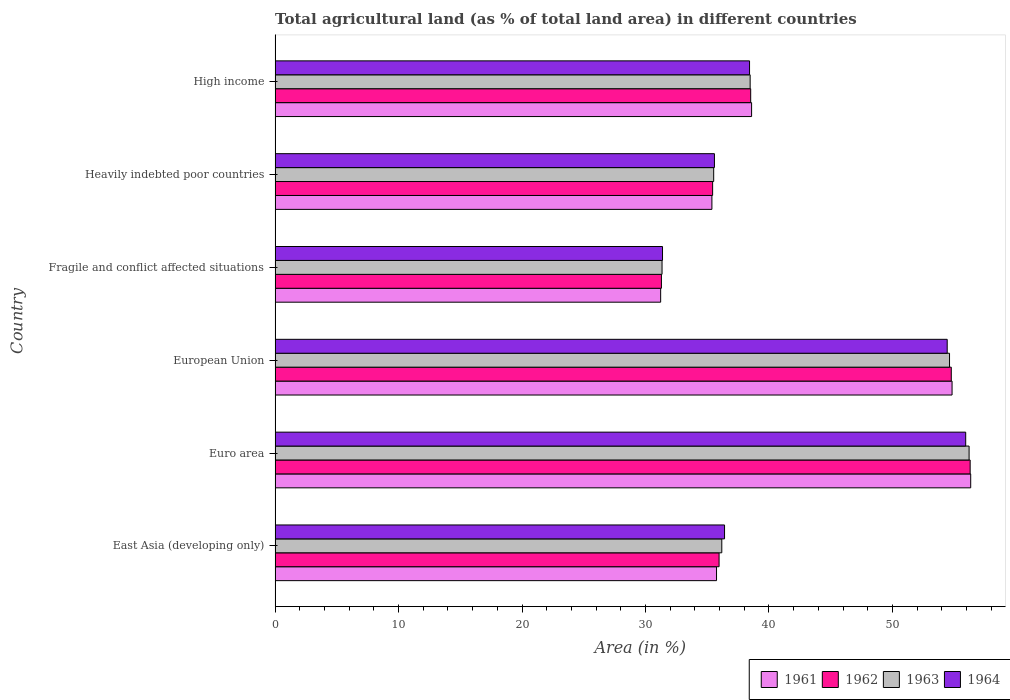Are the number of bars on each tick of the Y-axis equal?
Your answer should be very brief. Yes. How many bars are there on the 1st tick from the top?
Make the answer very short. 4. What is the label of the 5th group of bars from the top?
Your response must be concise. Euro area. In how many cases, is the number of bars for a given country not equal to the number of legend labels?
Provide a short and direct response. 0. What is the percentage of agricultural land in 1964 in Euro area?
Offer a terse response. 55.94. Across all countries, what is the maximum percentage of agricultural land in 1962?
Ensure brevity in your answer.  56.3. Across all countries, what is the minimum percentage of agricultural land in 1962?
Make the answer very short. 31.29. In which country was the percentage of agricultural land in 1963 maximum?
Provide a succinct answer. Euro area. In which country was the percentage of agricultural land in 1962 minimum?
Your answer should be compact. Fragile and conflict affected situations. What is the total percentage of agricultural land in 1961 in the graph?
Keep it short and to the point. 252.13. What is the difference between the percentage of agricultural land in 1961 in Euro area and that in High income?
Your response must be concise. 17.75. What is the difference between the percentage of agricultural land in 1961 in East Asia (developing only) and the percentage of agricultural land in 1964 in European Union?
Your answer should be very brief. -18.68. What is the average percentage of agricultural land in 1964 per country?
Keep it short and to the point. 42.03. What is the difference between the percentage of agricultural land in 1964 and percentage of agricultural land in 1961 in Euro area?
Your response must be concise. -0.4. In how many countries, is the percentage of agricultural land in 1963 greater than 46 %?
Keep it short and to the point. 2. What is the ratio of the percentage of agricultural land in 1963 in East Asia (developing only) to that in Fragile and conflict affected situations?
Give a very brief answer. 1.15. What is the difference between the highest and the second highest percentage of agricultural land in 1962?
Give a very brief answer. 1.53. What is the difference between the highest and the lowest percentage of agricultural land in 1964?
Offer a terse response. 24.56. Is the sum of the percentage of agricultural land in 1961 in Euro area and High income greater than the maximum percentage of agricultural land in 1964 across all countries?
Offer a terse response. Yes. Is it the case that in every country, the sum of the percentage of agricultural land in 1963 and percentage of agricultural land in 1964 is greater than the sum of percentage of agricultural land in 1961 and percentage of agricultural land in 1962?
Your answer should be very brief. No. What does the 1st bar from the top in Euro area represents?
Offer a very short reply. 1964. What does the 1st bar from the bottom in High income represents?
Offer a very short reply. 1961. Are all the bars in the graph horizontal?
Give a very brief answer. Yes. How many countries are there in the graph?
Make the answer very short. 6. Are the values on the major ticks of X-axis written in scientific E-notation?
Offer a terse response. No. Does the graph contain any zero values?
Keep it short and to the point. No. Does the graph contain grids?
Your answer should be very brief. No. How many legend labels are there?
Your answer should be compact. 4. How are the legend labels stacked?
Offer a very short reply. Horizontal. What is the title of the graph?
Your response must be concise. Total agricultural land (as % of total land area) in different countries. Does "1965" appear as one of the legend labels in the graph?
Keep it short and to the point. No. What is the label or title of the X-axis?
Keep it short and to the point. Area (in %). What is the label or title of the Y-axis?
Your answer should be compact. Country. What is the Area (in %) of 1961 in East Asia (developing only)?
Ensure brevity in your answer.  35.75. What is the Area (in %) of 1962 in East Asia (developing only)?
Make the answer very short. 35.96. What is the Area (in %) of 1963 in East Asia (developing only)?
Provide a short and direct response. 36.18. What is the Area (in %) of 1964 in East Asia (developing only)?
Your answer should be compact. 36.4. What is the Area (in %) in 1961 in Euro area?
Offer a terse response. 56.34. What is the Area (in %) of 1962 in Euro area?
Offer a terse response. 56.3. What is the Area (in %) of 1963 in Euro area?
Make the answer very short. 56.21. What is the Area (in %) of 1964 in Euro area?
Provide a short and direct response. 55.94. What is the Area (in %) of 1961 in European Union?
Keep it short and to the point. 54.83. What is the Area (in %) of 1962 in European Union?
Make the answer very short. 54.77. What is the Area (in %) of 1963 in European Union?
Your answer should be compact. 54.63. What is the Area (in %) in 1964 in European Union?
Ensure brevity in your answer.  54.44. What is the Area (in %) of 1961 in Fragile and conflict affected situations?
Ensure brevity in your answer.  31.23. What is the Area (in %) of 1962 in Fragile and conflict affected situations?
Provide a short and direct response. 31.29. What is the Area (in %) in 1963 in Fragile and conflict affected situations?
Your answer should be compact. 31.34. What is the Area (in %) of 1964 in Fragile and conflict affected situations?
Offer a terse response. 31.38. What is the Area (in %) of 1961 in Heavily indebted poor countries?
Provide a short and direct response. 35.38. What is the Area (in %) in 1962 in Heavily indebted poor countries?
Your response must be concise. 35.44. What is the Area (in %) in 1963 in Heavily indebted poor countries?
Offer a terse response. 35.52. What is the Area (in %) in 1964 in Heavily indebted poor countries?
Your response must be concise. 35.59. What is the Area (in %) in 1961 in High income?
Provide a succinct answer. 38.59. What is the Area (in %) of 1962 in High income?
Your answer should be compact. 38.52. What is the Area (in %) of 1963 in High income?
Keep it short and to the point. 38.48. What is the Area (in %) in 1964 in High income?
Your answer should be compact. 38.43. Across all countries, what is the maximum Area (in %) in 1961?
Keep it short and to the point. 56.34. Across all countries, what is the maximum Area (in %) in 1962?
Give a very brief answer. 56.3. Across all countries, what is the maximum Area (in %) in 1963?
Provide a succinct answer. 56.21. Across all countries, what is the maximum Area (in %) in 1964?
Keep it short and to the point. 55.94. Across all countries, what is the minimum Area (in %) in 1961?
Your answer should be compact. 31.23. Across all countries, what is the minimum Area (in %) of 1962?
Give a very brief answer. 31.29. Across all countries, what is the minimum Area (in %) in 1963?
Keep it short and to the point. 31.34. Across all countries, what is the minimum Area (in %) in 1964?
Keep it short and to the point. 31.38. What is the total Area (in %) in 1961 in the graph?
Give a very brief answer. 252.13. What is the total Area (in %) of 1962 in the graph?
Your response must be concise. 252.28. What is the total Area (in %) of 1963 in the graph?
Your response must be concise. 252.36. What is the total Area (in %) of 1964 in the graph?
Provide a short and direct response. 252.17. What is the difference between the Area (in %) in 1961 in East Asia (developing only) and that in Euro area?
Make the answer very short. -20.59. What is the difference between the Area (in %) in 1962 in East Asia (developing only) and that in Euro area?
Give a very brief answer. -20.34. What is the difference between the Area (in %) in 1963 in East Asia (developing only) and that in Euro area?
Provide a succinct answer. -20.03. What is the difference between the Area (in %) of 1964 in East Asia (developing only) and that in Euro area?
Keep it short and to the point. -19.53. What is the difference between the Area (in %) of 1961 in East Asia (developing only) and that in European Union?
Your answer should be compact. -19.08. What is the difference between the Area (in %) in 1962 in East Asia (developing only) and that in European Union?
Keep it short and to the point. -18.81. What is the difference between the Area (in %) in 1963 in East Asia (developing only) and that in European Union?
Ensure brevity in your answer.  -18.45. What is the difference between the Area (in %) in 1964 in East Asia (developing only) and that in European Union?
Ensure brevity in your answer.  -18.03. What is the difference between the Area (in %) in 1961 in East Asia (developing only) and that in Fragile and conflict affected situations?
Your answer should be very brief. 4.53. What is the difference between the Area (in %) of 1962 in East Asia (developing only) and that in Fragile and conflict affected situations?
Keep it short and to the point. 4.67. What is the difference between the Area (in %) of 1963 in East Asia (developing only) and that in Fragile and conflict affected situations?
Your response must be concise. 4.84. What is the difference between the Area (in %) of 1964 in East Asia (developing only) and that in Fragile and conflict affected situations?
Provide a short and direct response. 5.02. What is the difference between the Area (in %) of 1961 in East Asia (developing only) and that in Heavily indebted poor countries?
Your response must be concise. 0.37. What is the difference between the Area (in %) of 1962 in East Asia (developing only) and that in Heavily indebted poor countries?
Your response must be concise. 0.52. What is the difference between the Area (in %) of 1963 in East Asia (developing only) and that in Heavily indebted poor countries?
Ensure brevity in your answer.  0.66. What is the difference between the Area (in %) of 1964 in East Asia (developing only) and that in Heavily indebted poor countries?
Provide a succinct answer. 0.82. What is the difference between the Area (in %) of 1961 in East Asia (developing only) and that in High income?
Make the answer very short. -2.84. What is the difference between the Area (in %) of 1962 in East Asia (developing only) and that in High income?
Your answer should be compact. -2.56. What is the difference between the Area (in %) of 1963 in East Asia (developing only) and that in High income?
Provide a short and direct response. -2.3. What is the difference between the Area (in %) of 1964 in East Asia (developing only) and that in High income?
Ensure brevity in your answer.  -2.03. What is the difference between the Area (in %) of 1961 in Euro area and that in European Union?
Offer a terse response. 1.51. What is the difference between the Area (in %) of 1962 in Euro area and that in European Union?
Make the answer very short. 1.53. What is the difference between the Area (in %) in 1963 in Euro area and that in European Union?
Offer a very short reply. 1.58. What is the difference between the Area (in %) in 1964 in Euro area and that in European Union?
Ensure brevity in your answer.  1.5. What is the difference between the Area (in %) in 1961 in Euro area and that in Fragile and conflict affected situations?
Offer a terse response. 25.11. What is the difference between the Area (in %) of 1962 in Euro area and that in Fragile and conflict affected situations?
Your answer should be very brief. 25.01. What is the difference between the Area (in %) in 1963 in Euro area and that in Fragile and conflict affected situations?
Your response must be concise. 24.87. What is the difference between the Area (in %) in 1964 in Euro area and that in Fragile and conflict affected situations?
Your response must be concise. 24.56. What is the difference between the Area (in %) of 1961 in Euro area and that in Heavily indebted poor countries?
Offer a very short reply. 20.96. What is the difference between the Area (in %) of 1962 in Euro area and that in Heavily indebted poor countries?
Offer a terse response. 20.86. What is the difference between the Area (in %) in 1963 in Euro area and that in Heavily indebted poor countries?
Offer a very short reply. 20.69. What is the difference between the Area (in %) in 1964 in Euro area and that in Heavily indebted poor countries?
Your answer should be very brief. 20.35. What is the difference between the Area (in %) in 1961 in Euro area and that in High income?
Provide a succinct answer. 17.75. What is the difference between the Area (in %) of 1962 in Euro area and that in High income?
Give a very brief answer. 17.78. What is the difference between the Area (in %) in 1963 in Euro area and that in High income?
Keep it short and to the point. 17.73. What is the difference between the Area (in %) of 1964 in Euro area and that in High income?
Your answer should be compact. 17.51. What is the difference between the Area (in %) of 1961 in European Union and that in Fragile and conflict affected situations?
Provide a succinct answer. 23.6. What is the difference between the Area (in %) of 1962 in European Union and that in Fragile and conflict affected situations?
Provide a succinct answer. 23.48. What is the difference between the Area (in %) of 1963 in European Union and that in Fragile and conflict affected situations?
Ensure brevity in your answer.  23.28. What is the difference between the Area (in %) of 1964 in European Union and that in Fragile and conflict affected situations?
Offer a very short reply. 23.06. What is the difference between the Area (in %) in 1961 in European Union and that in Heavily indebted poor countries?
Make the answer very short. 19.45. What is the difference between the Area (in %) of 1962 in European Union and that in Heavily indebted poor countries?
Your response must be concise. 19.33. What is the difference between the Area (in %) in 1963 in European Union and that in Heavily indebted poor countries?
Your answer should be very brief. 19.1. What is the difference between the Area (in %) of 1964 in European Union and that in Heavily indebted poor countries?
Keep it short and to the point. 18.85. What is the difference between the Area (in %) of 1961 in European Union and that in High income?
Your answer should be compact. 16.24. What is the difference between the Area (in %) in 1962 in European Union and that in High income?
Provide a short and direct response. 16.25. What is the difference between the Area (in %) of 1963 in European Union and that in High income?
Offer a very short reply. 16.15. What is the difference between the Area (in %) in 1964 in European Union and that in High income?
Offer a very short reply. 16.01. What is the difference between the Area (in %) of 1961 in Fragile and conflict affected situations and that in Heavily indebted poor countries?
Offer a very short reply. -4.15. What is the difference between the Area (in %) in 1962 in Fragile and conflict affected situations and that in Heavily indebted poor countries?
Your answer should be very brief. -4.15. What is the difference between the Area (in %) in 1963 in Fragile and conflict affected situations and that in Heavily indebted poor countries?
Offer a terse response. -4.18. What is the difference between the Area (in %) in 1964 in Fragile and conflict affected situations and that in Heavily indebted poor countries?
Keep it short and to the point. -4.21. What is the difference between the Area (in %) of 1961 in Fragile and conflict affected situations and that in High income?
Make the answer very short. -7.37. What is the difference between the Area (in %) of 1962 in Fragile and conflict affected situations and that in High income?
Offer a terse response. -7.23. What is the difference between the Area (in %) in 1963 in Fragile and conflict affected situations and that in High income?
Your answer should be compact. -7.14. What is the difference between the Area (in %) in 1964 in Fragile and conflict affected situations and that in High income?
Ensure brevity in your answer.  -7.05. What is the difference between the Area (in %) in 1961 in Heavily indebted poor countries and that in High income?
Give a very brief answer. -3.21. What is the difference between the Area (in %) of 1962 in Heavily indebted poor countries and that in High income?
Make the answer very short. -3.08. What is the difference between the Area (in %) in 1963 in Heavily indebted poor countries and that in High income?
Provide a short and direct response. -2.95. What is the difference between the Area (in %) of 1964 in Heavily indebted poor countries and that in High income?
Make the answer very short. -2.84. What is the difference between the Area (in %) in 1961 in East Asia (developing only) and the Area (in %) in 1962 in Euro area?
Provide a succinct answer. -20.54. What is the difference between the Area (in %) of 1961 in East Asia (developing only) and the Area (in %) of 1963 in Euro area?
Your answer should be compact. -20.46. What is the difference between the Area (in %) in 1961 in East Asia (developing only) and the Area (in %) in 1964 in Euro area?
Give a very brief answer. -20.18. What is the difference between the Area (in %) of 1962 in East Asia (developing only) and the Area (in %) of 1963 in Euro area?
Offer a very short reply. -20.25. What is the difference between the Area (in %) in 1962 in East Asia (developing only) and the Area (in %) in 1964 in Euro area?
Make the answer very short. -19.98. What is the difference between the Area (in %) of 1963 in East Asia (developing only) and the Area (in %) of 1964 in Euro area?
Provide a short and direct response. -19.76. What is the difference between the Area (in %) of 1961 in East Asia (developing only) and the Area (in %) of 1962 in European Union?
Ensure brevity in your answer.  -19.01. What is the difference between the Area (in %) of 1961 in East Asia (developing only) and the Area (in %) of 1963 in European Union?
Keep it short and to the point. -18.87. What is the difference between the Area (in %) in 1961 in East Asia (developing only) and the Area (in %) in 1964 in European Union?
Ensure brevity in your answer.  -18.68. What is the difference between the Area (in %) in 1962 in East Asia (developing only) and the Area (in %) in 1963 in European Union?
Make the answer very short. -18.66. What is the difference between the Area (in %) of 1962 in East Asia (developing only) and the Area (in %) of 1964 in European Union?
Provide a short and direct response. -18.48. What is the difference between the Area (in %) of 1963 in East Asia (developing only) and the Area (in %) of 1964 in European Union?
Offer a very short reply. -18.26. What is the difference between the Area (in %) in 1961 in East Asia (developing only) and the Area (in %) in 1962 in Fragile and conflict affected situations?
Keep it short and to the point. 4.46. What is the difference between the Area (in %) of 1961 in East Asia (developing only) and the Area (in %) of 1963 in Fragile and conflict affected situations?
Make the answer very short. 4.41. What is the difference between the Area (in %) in 1961 in East Asia (developing only) and the Area (in %) in 1964 in Fragile and conflict affected situations?
Your response must be concise. 4.38. What is the difference between the Area (in %) in 1962 in East Asia (developing only) and the Area (in %) in 1963 in Fragile and conflict affected situations?
Your answer should be very brief. 4.62. What is the difference between the Area (in %) in 1962 in East Asia (developing only) and the Area (in %) in 1964 in Fragile and conflict affected situations?
Your response must be concise. 4.58. What is the difference between the Area (in %) in 1963 in East Asia (developing only) and the Area (in %) in 1964 in Fragile and conflict affected situations?
Provide a succinct answer. 4.8. What is the difference between the Area (in %) in 1961 in East Asia (developing only) and the Area (in %) in 1962 in Heavily indebted poor countries?
Provide a short and direct response. 0.32. What is the difference between the Area (in %) in 1961 in East Asia (developing only) and the Area (in %) in 1963 in Heavily indebted poor countries?
Your answer should be very brief. 0.23. What is the difference between the Area (in %) of 1961 in East Asia (developing only) and the Area (in %) of 1964 in Heavily indebted poor countries?
Keep it short and to the point. 0.17. What is the difference between the Area (in %) of 1962 in East Asia (developing only) and the Area (in %) of 1963 in Heavily indebted poor countries?
Keep it short and to the point. 0.44. What is the difference between the Area (in %) in 1962 in East Asia (developing only) and the Area (in %) in 1964 in Heavily indebted poor countries?
Keep it short and to the point. 0.38. What is the difference between the Area (in %) of 1963 in East Asia (developing only) and the Area (in %) of 1964 in Heavily indebted poor countries?
Your response must be concise. 0.6. What is the difference between the Area (in %) in 1961 in East Asia (developing only) and the Area (in %) in 1962 in High income?
Offer a very short reply. -2.77. What is the difference between the Area (in %) in 1961 in East Asia (developing only) and the Area (in %) in 1963 in High income?
Your answer should be very brief. -2.72. What is the difference between the Area (in %) in 1961 in East Asia (developing only) and the Area (in %) in 1964 in High income?
Make the answer very short. -2.67. What is the difference between the Area (in %) of 1962 in East Asia (developing only) and the Area (in %) of 1963 in High income?
Give a very brief answer. -2.52. What is the difference between the Area (in %) in 1962 in East Asia (developing only) and the Area (in %) in 1964 in High income?
Your answer should be compact. -2.47. What is the difference between the Area (in %) of 1963 in East Asia (developing only) and the Area (in %) of 1964 in High income?
Ensure brevity in your answer.  -2.25. What is the difference between the Area (in %) in 1961 in Euro area and the Area (in %) in 1962 in European Union?
Your answer should be very brief. 1.57. What is the difference between the Area (in %) of 1961 in Euro area and the Area (in %) of 1963 in European Union?
Ensure brevity in your answer.  1.72. What is the difference between the Area (in %) in 1961 in Euro area and the Area (in %) in 1964 in European Union?
Your answer should be very brief. 1.9. What is the difference between the Area (in %) of 1962 in Euro area and the Area (in %) of 1963 in European Union?
Provide a short and direct response. 1.67. What is the difference between the Area (in %) of 1962 in Euro area and the Area (in %) of 1964 in European Union?
Provide a succinct answer. 1.86. What is the difference between the Area (in %) in 1963 in Euro area and the Area (in %) in 1964 in European Union?
Offer a very short reply. 1.77. What is the difference between the Area (in %) of 1961 in Euro area and the Area (in %) of 1962 in Fragile and conflict affected situations?
Your answer should be compact. 25.05. What is the difference between the Area (in %) in 1961 in Euro area and the Area (in %) in 1963 in Fragile and conflict affected situations?
Offer a very short reply. 25. What is the difference between the Area (in %) of 1961 in Euro area and the Area (in %) of 1964 in Fragile and conflict affected situations?
Provide a succinct answer. 24.96. What is the difference between the Area (in %) in 1962 in Euro area and the Area (in %) in 1963 in Fragile and conflict affected situations?
Offer a terse response. 24.95. What is the difference between the Area (in %) in 1962 in Euro area and the Area (in %) in 1964 in Fragile and conflict affected situations?
Your answer should be compact. 24.92. What is the difference between the Area (in %) in 1963 in Euro area and the Area (in %) in 1964 in Fragile and conflict affected situations?
Keep it short and to the point. 24.83. What is the difference between the Area (in %) of 1961 in Euro area and the Area (in %) of 1962 in Heavily indebted poor countries?
Give a very brief answer. 20.9. What is the difference between the Area (in %) in 1961 in Euro area and the Area (in %) in 1963 in Heavily indebted poor countries?
Provide a short and direct response. 20.82. What is the difference between the Area (in %) in 1961 in Euro area and the Area (in %) in 1964 in Heavily indebted poor countries?
Keep it short and to the point. 20.76. What is the difference between the Area (in %) of 1962 in Euro area and the Area (in %) of 1963 in Heavily indebted poor countries?
Provide a succinct answer. 20.77. What is the difference between the Area (in %) in 1962 in Euro area and the Area (in %) in 1964 in Heavily indebted poor countries?
Provide a short and direct response. 20.71. What is the difference between the Area (in %) of 1963 in Euro area and the Area (in %) of 1964 in Heavily indebted poor countries?
Offer a terse response. 20.63. What is the difference between the Area (in %) in 1961 in Euro area and the Area (in %) in 1962 in High income?
Provide a short and direct response. 17.82. What is the difference between the Area (in %) in 1961 in Euro area and the Area (in %) in 1963 in High income?
Provide a succinct answer. 17.86. What is the difference between the Area (in %) in 1961 in Euro area and the Area (in %) in 1964 in High income?
Provide a succinct answer. 17.91. What is the difference between the Area (in %) in 1962 in Euro area and the Area (in %) in 1963 in High income?
Keep it short and to the point. 17.82. What is the difference between the Area (in %) of 1962 in Euro area and the Area (in %) of 1964 in High income?
Give a very brief answer. 17.87. What is the difference between the Area (in %) of 1963 in Euro area and the Area (in %) of 1964 in High income?
Ensure brevity in your answer.  17.78. What is the difference between the Area (in %) of 1961 in European Union and the Area (in %) of 1962 in Fragile and conflict affected situations?
Offer a terse response. 23.54. What is the difference between the Area (in %) of 1961 in European Union and the Area (in %) of 1963 in Fragile and conflict affected situations?
Your response must be concise. 23.49. What is the difference between the Area (in %) of 1961 in European Union and the Area (in %) of 1964 in Fragile and conflict affected situations?
Your response must be concise. 23.45. What is the difference between the Area (in %) in 1962 in European Union and the Area (in %) in 1963 in Fragile and conflict affected situations?
Make the answer very short. 23.43. What is the difference between the Area (in %) in 1962 in European Union and the Area (in %) in 1964 in Fragile and conflict affected situations?
Your response must be concise. 23.39. What is the difference between the Area (in %) in 1963 in European Union and the Area (in %) in 1964 in Fragile and conflict affected situations?
Your answer should be compact. 23.25. What is the difference between the Area (in %) of 1961 in European Union and the Area (in %) of 1962 in Heavily indebted poor countries?
Ensure brevity in your answer.  19.39. What is the difference between the Area (in %) of 1961 in European Union and the Area (in %) of 1963 in Heavily indebted poor countries?
Make the answer very short. 19.31. What is the difference between the Area (in %) in 1961 in European Union and the Area (in %) in 1964 in Heavily indebted poor countries?
Offer a terse response. 19.25. What is the difference between the Area (in %) in 1962 in European Union and the Area (in %) in 1963 in Heavily indebted poor countries?
Offer a terse response. 19.24. What is the difference between the Area (in %) of 1962 in European Union and the Area (in %) of 1964 in Heavily indebted poor countries?
Give a very brief answer. 19.18. What is the difference between the Area (in %) of 1963 in European Union and the Area (in %) of 1964 in Heavily indebted poor countries?
Provide a succinct answer. 19.04. What is the difference between the Area (in %) in 1961 in European Union and the Area (in %) in 1962 in High income?
Your response must be concise. 16.31. What is the difference between the Area (in %) of 1961 in European Union and the Area (in %) of 1963 in High income?
Your answer should be compact. 16.35. What is the difference between the Area (in %) in 1961 in European Union and the Area (in %) in 1964 in High income?
Provide a succinct answer. 16.4. What is the difference between the Area (in %) in 1962 in European Union and the Area (in %) in 1963 in High income?
Provide a succinct answer. 16.29. What is the difference between the Area (in %) of 1962 in European Union and the Area (in %) of 1964 in High income?
Ensure brevity in your answer.  16.34. What is the difference between the Area (in %) in 1963 in European Union and the Area (in %) in 1964 in High income?
Give a very brief answer. 16.2. What is the difference between the Area (in %) of 1961 in Fragile and conflict affected situations and the Area (in %) of 1962 in Heavily indebted poor countries?
Offer a terse response. -4.21. What is the difference between the Area (in %) of 1961 in Fragile and conflict affected situations and the Area (in %) of 1963 in Heavily indebted poor countries?
Keep it short and to the point. -4.3. What is the difference between the Area (in %) in 1961 in Fragile and conflict affected situations and the Area (in %) in 1964 in Heavily indebted poor countries?
Offer a very short reply. -4.36. What is the difference between the Area (in %) of 1962 in Fragile and conflict affected situations and the Area (in %) of 1963 in Heavily indebted poor countries?
Make the answer very short. -4.23. What is the difference between the Area (in %) in 1962 in Fragile and conflict affected situations and the Area (in %) in 1964 in Heavily indebted poor countries?
Make the answer very short. -4.29. What is the difference between the Area (in %) of 1963 in Fragile and conflict affected situations and the Area (in %) of 1964 in Heavily indebted poor countries?
Keep it short and to the point. -4.24. What is the difference between the Area (in %) of 1961 in Fragile and conflict affected situations and the Area (in %) of 1962 in High income?
Offer a very short reply. -7.29. What is the difference between the Area (in %) of 1961 in Fragile and conflict affected situations and the Area (in %) of 1963 in High income?
Offer a terse response. -7.25. What is the difference between the Area (in %) of 1961 in Fragile and conflict affected situations and the Area (in %) of 1964 in High income?
Your response must be concise. -7.2. What is the difference between the Area (in %) in 1962 in Fragile and conflict affected situations and the Area (in %) in 1963 in High income?
Your answer should be very brief. -7.19. What is the difference between the Area (in %) of 1962 in Fragile and conflict affected situations and the Area (in %) of 1964 in High income?
Offer a terse response. -7.14. What is the difference between the Area (in %) in 1963 in Fragile and conflict affected situations and the Area (in %) in 1964 in High income?
Make the answer very short. -7.09. What is the difference between the Area (in %) in 1961 in Heavily indebted poor countries and the Area (in %) in 1962 in High income?
Your response must be concise. -3.14. What is the difference between the Area (in %) in 1961 in Heavily indebted poor countries and the Area (in %) in 1963 in High income?
Provide a succinct answer. -3.1. What is the difference between the Area (in %) in 1961 in Heavily indebted poor countries and the Area (in %) in 1964 in High income?
Your response must be concise. -3.05. What is the difference between the Area (in %) of 1962 in Heavily indebted poor countries and the Area (in %) of 1963 in High income?
Offer a very short reply. -3.04. What is the difference between the Area (in %) in 1962 in Heavily indebted poor countries and the Area (in %) in 1964 in High income?
Make the answer very short. -2.99. What is the difference between the Area (in %) of 1963 in Heavily indebted poor countries and the Area (in %) of 1964 in High income?
Ensure brevity in your answer.  -2.9. What is the average Area (in %) of 1961 per country?
Your answer should be compact. 42.02. What is the average Area (in %) in 1962 per country?
Offer a terse response. 42.05. What is the average Area (in %) in 1963 per country?
Provide a succinct answer. 42.06. What is the average Area (in %) in 1964 per country?
Ensure brevity in your answer.  42.03. What is the difference between the Area (in %) of 1961 and Area (in %) of 1962 in East Asia (developing only)?
Keep it short and to the point. -0.21. What is the difference between the Area (in %) of 1961 and Area (in %) of 1963 in East Asia (developing only)?
Your response must be concise. -0.43. What is the difference between the Area (in %) of 1961 and Area (in %) of 1964 in East Asia (developing only)?
Keep it short and to the point. -0.65. What is the difference between the Area (in %) in 1962 and Area (in %) in 1963 in East Asia (developing only)?
Offer a very short reply. -0.22. What is the difference between the Area (in %) of 1962 and Area (in %) of 1964 in East Asia (developing only)?
Offer a very short reply. -0.44. What is the difference between the Area (in %) in 1963 and Area (in %) in 1964 in East Asia (developing only)?
Provide a short and direct response. -0.22. What is the difference between the Area (in %) of 1961 and Area (in %) of 1962 in Euro area?
Offer a terse response. 0.05. What is the difference between the Area (in %) in 1961 and Area (in %) in 1963 in Euro area?
Your answer should be very brief. 0.13. What is the difference between the Area (in %) in 1961 and Area (in %) in 1964 in Euro area?
Ensure brevity in your answer.  0.41. What is the difference between the Area (in %) in 1962 and Area (in %) in 1963 in Euro area?
Keep it short and to the point. 0.09. What is the difference between the Area (in %) in 1962 and Area (in %) in 1964 in Euro area?
Offer a very short reply. 0.36. What is the difference between the Area (in %) of 1963 and Area (in %) of 1964 in Euro area?
Offer a very short reply. 0.27. What is the difference between the Area (in %) in 1961 and Area (in %) in 1962 in European Union?
Your response must be concise. 0.06. What is the difference between the Area (in %) of 1961 and Area (in %) of 1963 in European Union?
Keep it short and to the point. 0.21. What is the difference between the Area (in %) of 1961 and Area (in %) of 1964 in European Union?
Your response must be concise. 0.39. What is the difference between the Area (in %) in 1962 and Area (in %) in 1963 in European Union?
Your answer should be very brief. 0.14. What is the difference between the Area (in %) of 1962 and Area (in %) of 1964 in European Union?
Ensure brevity in your answer.  0.33. What is the difference between the Area (in %) in 1963 and Area (in %) in 1964 in European Union?
Make the answer very short. 0.19. What is the difference between the Area (in %) of 1961 and Area (in %) of 1962 in Fragile and conflict affected situations?
Your response must be concise. -0.06. What is the difference between the Area (in %) in 1961 and Area (in %) in 1963 in Fragile and conflict affected situations?
Your answer should be compact. -0.11. What is the difference between the Area (in %) of 1961 and Area (in %) of 1964 in Fragile and conflict affected situations?
Make the answer very short. -0.15. What is the difference between the Area (in %) in 1962 and Area (in %) in 1963 in Fragile and conflict affected situations?
Give a very brief answer. -0.05. What is the difference between the Area (in %) in 1962 and Area (in %) in 1964 in Fragile and conflict affected situations?
Offer a very short reply. -0.09. What is the difference between the Area (in %) of 1963 and Area (in %) of 1964 in Fragile and conflict affected situations?
Your response must be concise. -0.04. What is the difference between the Area (in %) in 1961 and Area (in %) in 1962 in Heavily indebted poor countries?
Keep it short and to the point. -0.06. What is the difference between the Area (in %) in 1961 and Area (in %) in 1963 in Heavily indebted poor countries?
Give a very brief answer. -0.14. What is the difference between the Area (in %) in 1961 and Area (in %) in 1964 in Heavily indebted poor countries?
Make the answer very short. -0.2. What is the difference between the Area (in %) in 1962 and Area (in %) in 1963 in Heavily indebted poor countries?
Your answer should be compact. -0.09. What is the difference between the Area (in %) in 1962 and Area (in %) in 1964 in Heavily indebted poor countries?
Provide a succinct answer. -0.15. What is the difference between the Area (in %) of 1963 and Area (in %) of 1964 in Heavily indebted poor countries?
Your answer should be compact. -0.06. What is the difference between the Area (in %) in 1961 and Area (in %) in 1962 in High income?
Your response must be concise. 0.07. What is the difference between the Area (in %) of 1961 and Area (in %) of 1963 in High income?
Ensure brevity in your answer.  0.12. What is the difference between the Area (in %) in 1961 and Area (in %) in 1964 in High income?
Provide a succinct answer. 0.17. What is the difference between the Area (in %) of 1962 and Area (in %) of 1963 in High income?
Offer a very short reply. 0.04. What is the difference between the Area (in %) in 1962 and Area (in %) in 1964 in High income?
Your answer should be compact. 0.09. What is the difference between the Area (in %) of 1963 and Area (in %) of 1964 in High income?
Make the answer very short. 0.05. What is the ratio of the Area (in %) in 1961 in East Asia (developing only) to that in Euro area?
Keep it short and to the point. 0.63. What is the ratio of the Area (in %) of 1962 in East Asia (developing only) to that in Euro area?
Provide a short and direct response. 0.64. What is the ratio of the Area (in %) of 1963 in East Asia (developing only) to that in Euro area?
Provide a short and direct response. 0.64. What is the ratio of the Area (in %) of 1964 in East Asia (developing only) to that in Euro area?
Ensure brevity in your answer.  0.65. What is the ratio of the Area (in %) of 1961 in East Asia (developing only) to that in European Union?
Your answer should be very brief. 0.65. What is the ratio of the Area (in %) in 1962 in East Asia (developing only) to that in European Union?
Your response must be concise. 0.66. What is the ratio of the Area (in %) in 1963 in East Asia (developing only) to that in European Union?
Provide a short and direct response. 0.66. What is the ratio of the Area (in %) in 1964 in East Asia (developing only) to that in European Union?
Provide a succinct answer. 0.67. What is the ratio of the Area (in %) of 1961 in East Asia (developing only) to that in Fragile and conflict affected situations?
Your answer should be very brief. 1.14. What is the ratio of the Area (in %) of 1962 in East Asia (developing only) to that in Fragile and conflict affected situations?
Your answer should be very brief. 1.15. What is the ratio of the Area (in %) in 1963 in East Asia (developing only) to that in Fragile and conflict affected situations?
Offer a terse response. 1.15. What is the ratio of the Area (in %) in 1964 in East Asia (developing only) to that in Fragile and conflict affected situations?
Offer a terse response. 1.16. What is the ratio of the Area (in %) of 1961 in East Asia (developing only) to that in Heavily indebted poor countries?
Your answer should be compact. 1.01. What is the ratio of the Area (in %) in 1962 in East Asia (developing only) to that in Heavily indebted poor countries?
Your answer should be compact. 1.01. What is the ratio of the Area (in %) in 1963 in East Asia (developing only) to that in Heavily indebted poor countries?
Give a very brief answer. 1.02. What is the ratio of the Area (in %) in 1961 in East Asia (developing only) to that in High income?
Give a very brief answer. 0.93. What is the ratio of the Area (in %) in 1962 in East Asia (developing only) to that in High income?
Your answer should be very brief. 0.93. What is the ratio of the Area (in %) of 1963 in East Asia (developing only) to that in High income?
Provide a short and direct response. 0.94. What is the ratio of the Area (in %) of 1964 in East Asia (developing only) to that in High income?
Ensure brevity in your answer.  0.95. What is the ratio of the Area (in %) in 1961 in Euro area to that in European Union?
Offer a very short reply. 1.03. What is the ratio of the Area (in %) in 1962 in Euro area to that in European Union?
Offer a very short reply. 1.03. What is the ratio of the Area (in %) of 1963 in Euro area to that in European Union?
Provide a succinct answer. 1.03. What is the ratio of the Area (in %) of 1964 in Euro area to that in European Union?
Your answer should be very brief. 1.03. What is the ratio of the Area (in %) in 1961 in Euro area to that in Fragile and conflict affected situations?
Keep it short and to the point. 1.8. What is the ratio of the Area (in %) of 1962 in Euro area to that in Fragile and conflict affected situations?
Your answer should be compact. 1.8. What is the ratio of the Area (in %) in 1963 in Euro area to that in Fragile and conflict affected situations?
Keep it short and to the point. 1.79. What is the ratio of the Area (in %) in 1964 in Euro area to that in Fragile and conflict affected situations?
Make the answer very short. 1.78. What is the ratio of the Area (in %) of 1961 in Euro area to that in Heavily indebted poor countries?
Provide a succinct answer. 1.59. What is the ratio of the Area (in %) in 1962 in Euro area to that in Heavily indebted poor countries?
Make the answer very short. 1.59. What is the ratio of the Area (in %) in 1963 in Euro area to that in Heavily indebted poor countries?
Your answer should be compact. 1.58. What is the ratio of the Area (in %) in 1964 in Euro area to that in Heavily indebted poor countries?
Provide a short and direct response. 1.57. What is the ratio of the Area (in %) in 1961 in Euro area to that in High income?
Give a very brief answer. 1.46. What is the ratio of the Area (in %) in 1962 in Euro area to that in High income?
Make the answer very short. 1.46. What is the ratio of the Area (in %) of 1963 in Euro area to that in High income?
Your answer should be very brief. 1.46. What is the ratio of the Area (in %) of 1964 in Euro area to that in High income?
Keep it short and to the point. 1.46. What is the ratio of the Area (in %) of 1961 in European Union to that in Fragile and conflict affected situations?
Offer a terse response. 1.76. What is the ratio of the Area (in %) in 1962 in European Union to that in Fragile and conflict affected situations?
Your response must be concise. 1.75. What is the ratio of the Area (in %) of 1963 in European Union to that in Fragile and conflict affected situations?
Your response must be concise. 1.74. What is the ratio of the Area (in %) of 1964 in European Union to that in Fragile and conflict affected situations?
Make the answer very short. 1.73. What is the ratio of the Area (in %) in 1961 in European Union to that in Heavily indebted poor countries?
Offer a terse response. 1.55. What is the ratio of the Area (in %) in 1962 in European Union to that in Heavily indebted poor countries?
Provide a succinct answer. 1.55. What is the ratio of the Area (in %) in 1963 in European Union to that in Heavily indebted poor countries?
Keep it short and to the point. 1.54. What is the ratio of the Area (in %) of 1964 in European Union to that in Heavily indebted poor countries?
Offer a very short reply. 1.53. What is the ratio of the Area (in %) of 1961 in European Union to that in High income?
Offer a very short reply. 1.42. What is the ratio of the Area (in %) in 1962 in European Union to that in High income?
Offer a terse response. 1.42. What is the ratio of the Area (in %) in 1963 in European Union to that in High income?
Give a very brief answer. 1.42. What is the ratio of the Area (in %) of 1964 in European Union to that in High income?
Keep it short and to the point. 1.42. What is the ratio of the Area (in %) of 1961 in Fragile and conflict affected situations to that in Heavily indebted poor countries?
Give a very brief answer. 0.88. What is the ratio of the Area (in %) in 1962 in Fragile and conflict affected situations to that in Heavily indebted poor countries?
Provide a short and direct response. 0.88. What is the ratio of the Area (in %) in 1963 in Fragile and conflict affected situations to that in Heavily indebted poor countries?
Make the answer very short. 0.88. What is the ratio of the Area (in %) of 1964 in Fragile and conflict affected situations to that in Heavily indebted poor countries?
Give a very brief answer. 0.88. What is the ratio of the Area (in %) in 1961 in Fragile and conflict affected situations to that in High income?
Give a very brief answer. 0.81. What is the ratio of the Area (in %) in 1962 in Fragile and conflict affected situations to that in High income?
Offer a very short reply. 0.81. What is the ratio of the Area (in %) of 1963 in Fragile and conflict affected situations to that in High income?
Your response must be concise. 0.81. What is the ratio of the Area (in %) of 1964 in Fragile and conflict affected situations to that in High income?
Your answer should be compact. 0.82. What is the ratio of the Area (in %) of 1963 in Heavily indebted poor countries to that in High income?
Offer a very short reply. 0.92. What is the ratio of the Area (in %) in 1964 in Heavily indebted poor countries to that in High income?
Provide a succinct answer. 0.93. What is the difference between the highest and the second highest Area (in %) of 1961?
Your answer should be compact. 1.51. What is the difference between the highest and the second highest Area (in %) of 1962?
Offer a very short reply. 1.53. What is the difference between the highest and the second highest Area (in %) in 1963?
Offer a very short reply. 1.58. What is the difference between the highest and the second highest Area (in %) of 1964?
Provide a succinct answer. 1.5. What is the difference between the highest and the lowest Area (in %) of 1961?
Your answer should be compact. 25.11. What is the difference between the highest and the lowest Area (in %) of 1962?
Keep it short and to the point. 25.01. What is the difference between the highest and the lowest Area (in %) of 1963?
Provide a succinct answer. 24.87. What is the difference between the highest and the lowest Area (in %) of 1964?
Offer a very short reply. 24.56. 